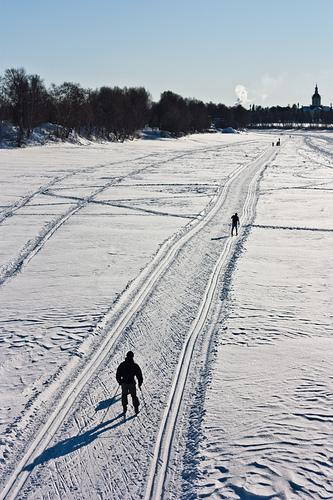Mention an object that is reflecting off the snow. A shadow is reflecting off the snow. Explain the condition of the snow in detail. The snow is white, tightly packed, and has tracks from different sources like skiers and vehicles. Describe the state of the trees in the picture. Full but brown, deciduous trees in winter. What is the most noticeable building in the background of the image? A church-like building with a pointy structure. What kind of tracks are present in the snow? Tracks from a vehicle, cross country skiers, and ridges. Quantify the number of people engaging in cross country skiing in the image. At least three people are cross country skiing. What unusual element can be seen in the sky? A cloud of smoke or steam is present in the sky. Identify the main activity taking place in the image. Cross country skiing on a snowy field. Provide a brief sentiment analysis of the image. The image has a calm and peaceful atmosphere with people enjoying cross country skiing in a snow-covered landscape. How many ski poles are visible in the image? At least two ski poles are visible. Describe the image focusing on the natural elements. A snowy field bordered by brown trees, with ski tracks meandering through the white expanse. Is the smoke or steam coming from a vehicle on the left side of the image? There is no mention of a vehicle on the left side of the image; the smoke or steam is coming from a separate source. Seeing the trees in the image, describe the season. winter Are the trees surrounding the field green and full of leaves? The trees are described as full but brown, implying that they are not filled with green leaves. What type of trees are in the image? deciduous trees Are there multiple clouds in the sky forming a cloudy environment? No, it's not mentioned in the image. How would you describe the building behind the trees? tall and pointy, possibly a church Are there multiple people cross country skiing in the image? Choose from Yes or No. Yes Can you detect the presence of a church in the distance? Yes, there is a church in the distance. Write a Haiku poem using the image as inspiration. Snow blankets the field What is the large snow-covered area called? a large snow-covered field How would you describe the appearance of the tracks from the vehicle in the snow? wide tracks in the snow Using a single word, describe the emotion of the person in heavy clothing. indeterminable Based on the photograph, what might be causing the smoke or steam in the distanced area? potentially a chimney or building heating system Spot any distant people in the image. Yes, there are people in the distance. Describe the ski poles observed in the image. one or more of the skiers are holding the ski poles What is the main activity between the people in the image? cross country skiing What is the white, puffy object in the sky? a small puffy white cloud Deducing by the tracks, did a person or vehicle primarily make these tracks? both a vehicle and cross-country skiers Compose a short story based on the image, incorporating cross-country skiers and trees. On a serene winter's day, two friends ventured out to explore the snow-covered field. The trees had shed their leaves, and only their brown branches revealed their presence. As the friends glided through the stark landscape on their skis, the distant church's spire stood witness to their journey. Describe the scene using a poetic phrase. A crisp winter's day, trees bare and brown, skiers glide through the glistening snow. How are the tracks in the snow formed? by a vehicle and cross-country skiers Is the snow rough or smooth in the large snow-covered field? tightly-packed, potentially with ripples or ridges 